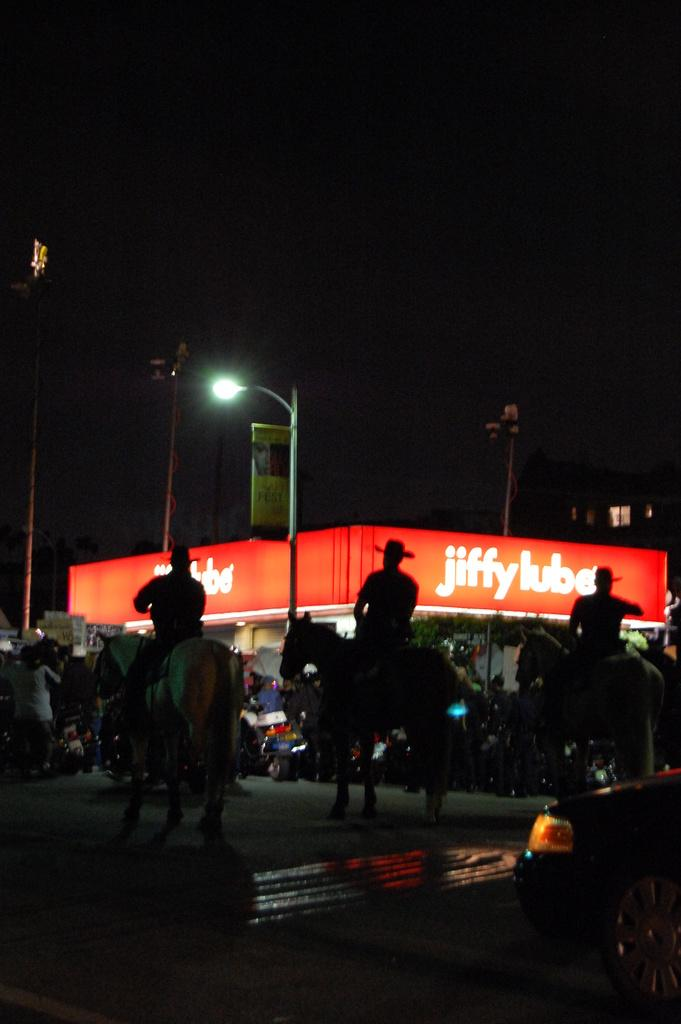What can be seen in the image that provides illumination? There is a light in the image. What type of signage is present in the image? There is a banner in the image. What are the people in the image doing? The people in the image are sitting on horses. Where are the kittens hiding in the image? There are no kittens present in the image. What type of surprise can be seen in the image? There is no surprise depicted in the image. 